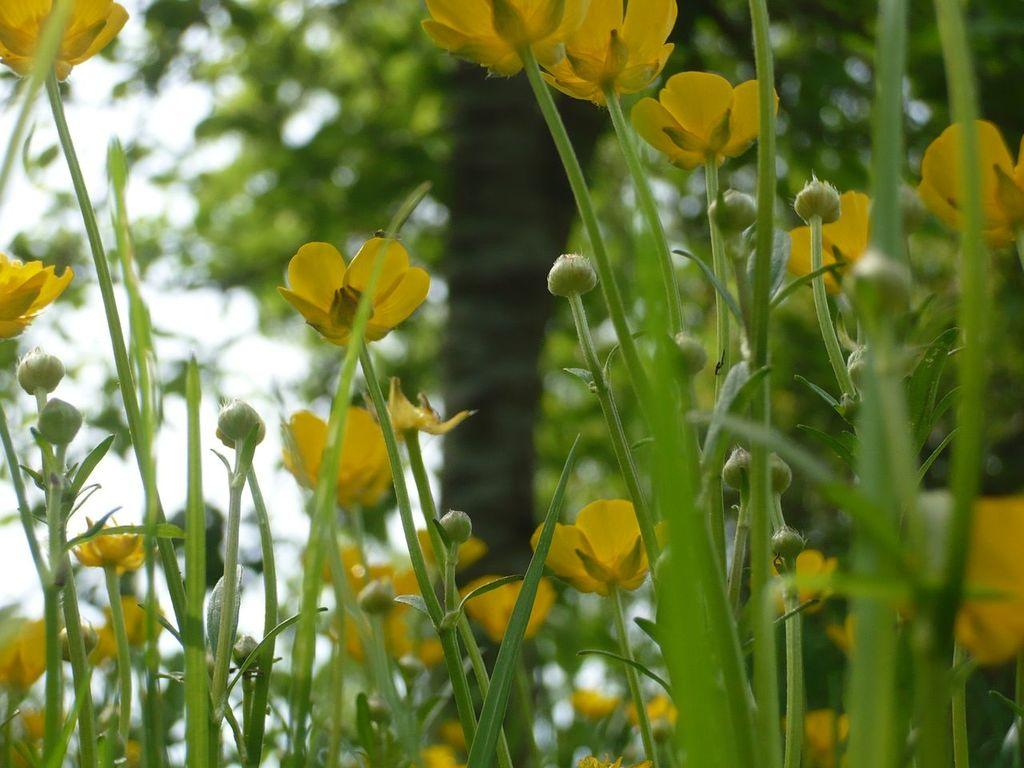What type of flowers are present in the image? The image contains yellow flowers. What other types of plants can be seen in the image? There are small plants at the bottom of the image. What can be seen in the background of the image? There is a tree in the background of the image. What word is written on the card in the image? There is no card present in the image, so it is not possible to answer that question. 